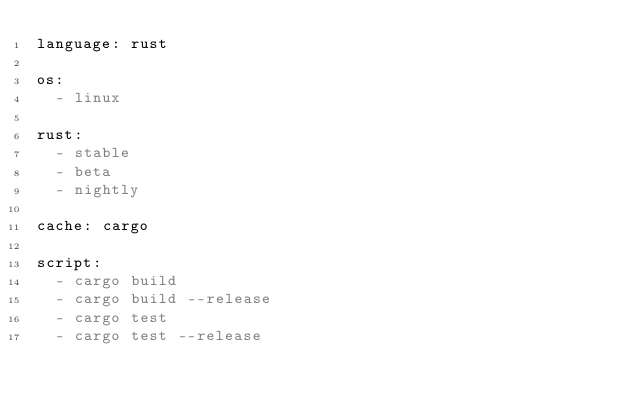<code> <loc_0><loc_0><loc_500><loc_500><_YAML_>language: rust

os:
  - linux

rust:
  - stable
  - beta
  - nightly

cache: cargo

script:
  - cargo build
  - cargo build --release
  - cargo test
  - cargo test --release
</code> 